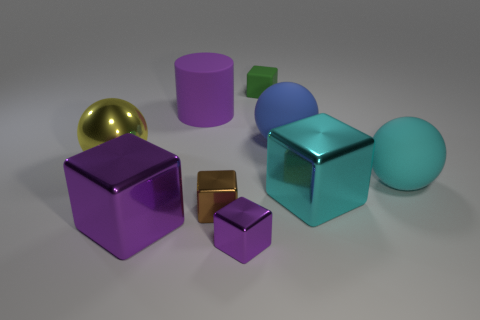What can you infer about the lighting and shadows in the scene? The lighting in the scene is diffused, producing soft shadows that gently stretch across the surface the objects rest upon. There is no harsh direct light, indicated by the lack of very dark or sharp-edged shadows. This suggests an indoor setting with either well-distributed artificial light or natural light filtered through a window. The reflections on the metallic surfaces further reveal that the light sources are likely positioned above and to the sides of the objects. 